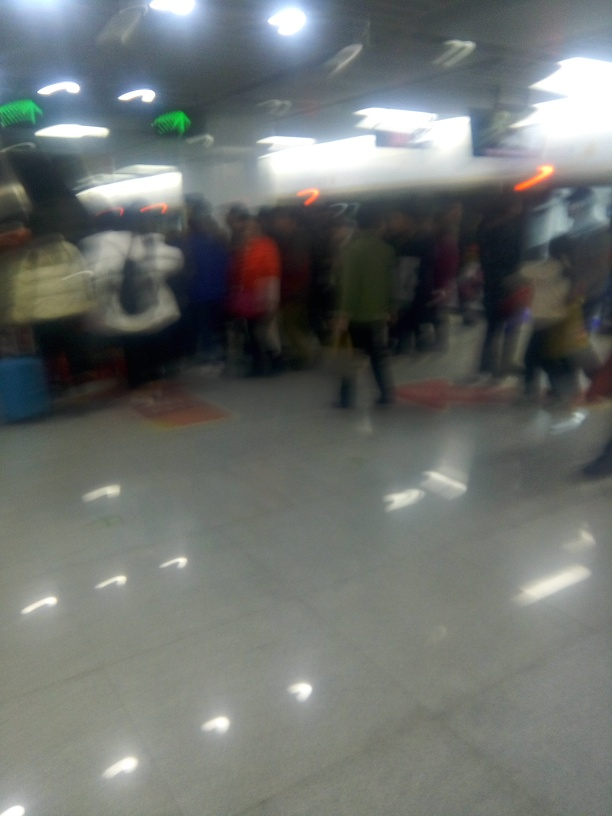What can we infer about the people in this image? Despite the poor image quality, it's apparent that the space is crowded, suggesting that the individuals are possibly commuters or travelers. The variety in clothing styles could also provide some clues to the demographics or the season in which the photo was taken. 